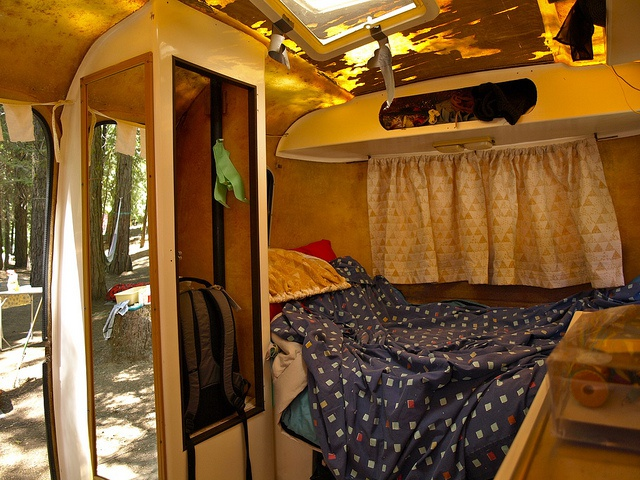Describe the objects in this image and their specific colors. I can see bed in maroon, black, and gray tones and backpack in maroon, black, and brown tones in this image. 